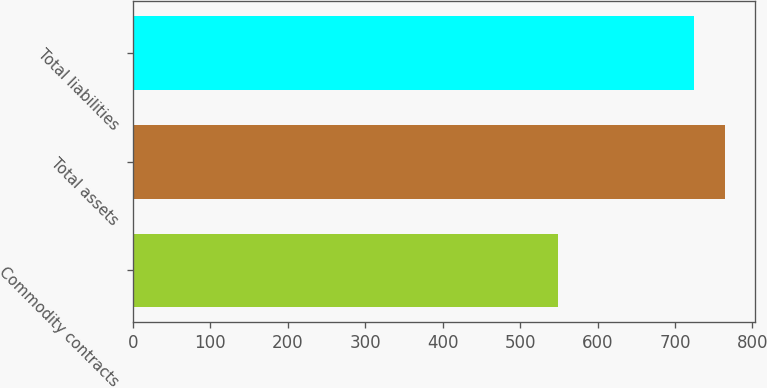Convert chart. <chart><loc_0><loc_0><loc_500><loc_500><bar_chart><fcel>Commodity contracts<fcel>Total assets<fcel>Total liabilities<nl><fcel>549<fcel>765<fcel>724<nl></chart> 